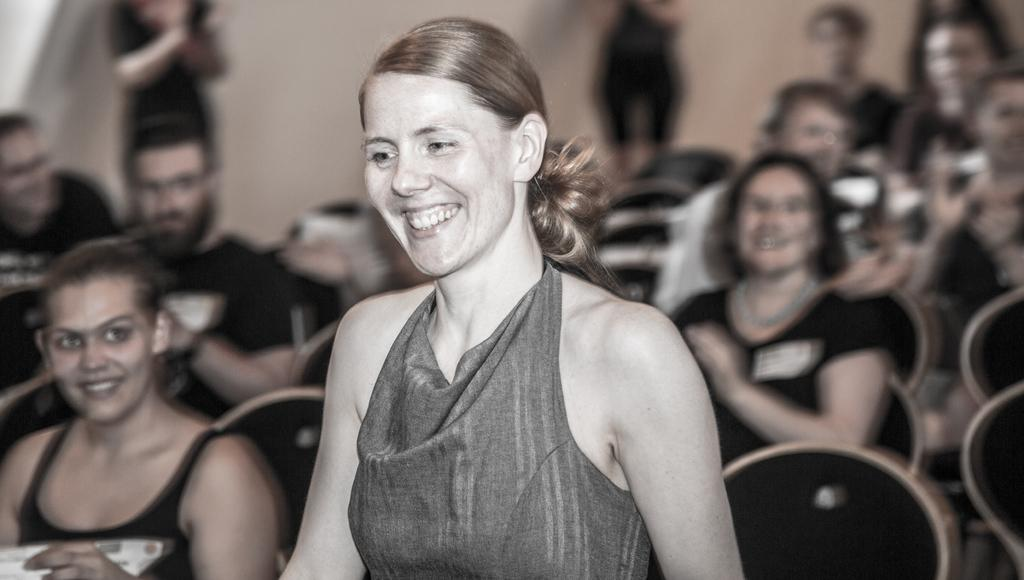How many people are in the image? There is a group of people in the image. What are the people in the image doing? Some people are seated, while others are standing. Can you describe the woman in the middle of the image? There is a woman in the middle of the image, and she is smiling. What type of salt is being used by the people in the image? There is no salt present in the image. How many degrees are the people in the image wearing? The provided facts do not mention the temperature or clothing of the people in the image, so it is impossible to determine the degrees they are wearing. 